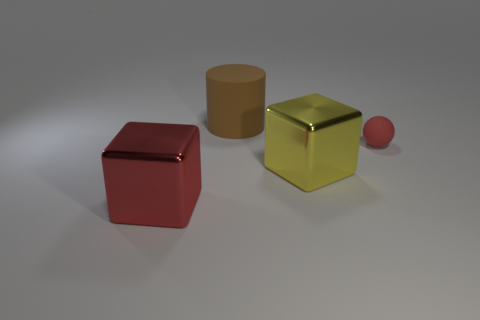How many other things are the same shape as the brown thing?
Give a very brief answer. 0. Do the red object that is in front of the red rubber ball and the cylinder have the same material?
Your response must be concise. No. How many things are tiny gray metal cylinders or large brown things?
Offer a very short reply. 1. There is another metallic object that is the same shape as the red shiny object; what is its size?
Your answer should be compact. Large. How big is the matte cylinder?
Your answer should be compact. Large. Is the number of large matte objects behind the red matte sphere greater than the number of big gray rubber blocks?
Give a very brief answer. Yes. There is a large metal block that is left of the large yellow shiny object; is its color the same as the matte object that is to the right of the large yellow cube?
Your answer should be very brief. Yes. What material is the block right of the red object left of the large cube to the right of the big brown object?
Give a very brief answer. Metal. Are there more tiny balls than tiny purple shiny spheres?
Offer a very short reply. Yes. Is there anything else of the same color as the big matte object?
Ensure brevity in your answer.  No. 